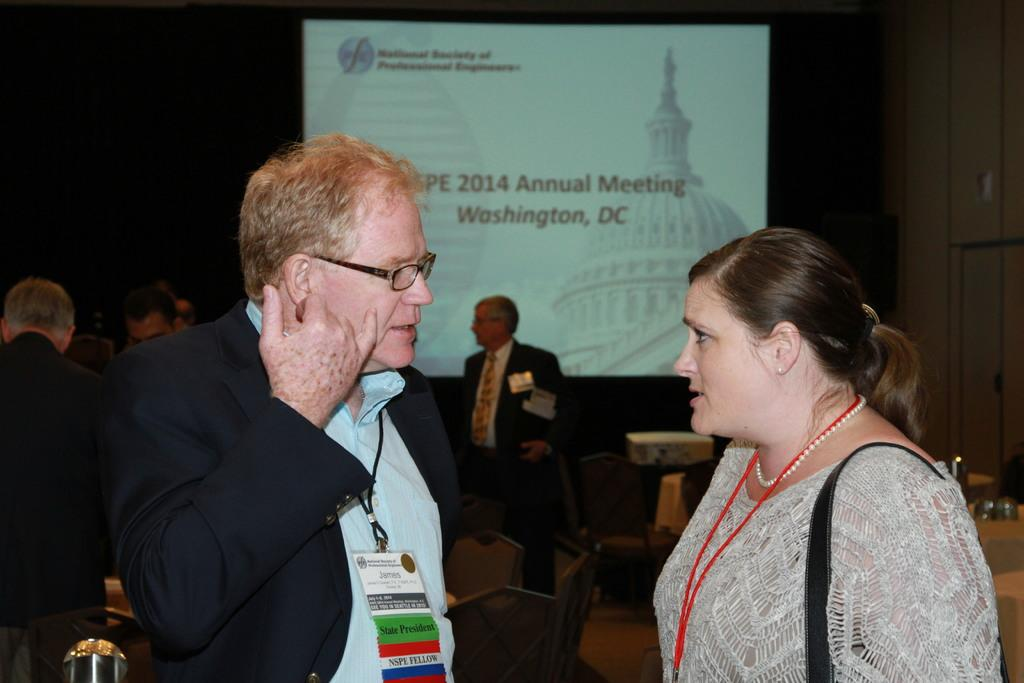How many people are in the image? There are persons standing in the image. What is the surface on which the persons are standing? The persons are standing on the floor. What objects are present between the persons? Chairs are present between the persons. What can be seen in the background of the image? There is a wall in the background of the image. What is on the wall in the image? There is a display on the wall. Can you tell me how many ladybugs are crawling on the display in the image? There are no ladybugs present in the image; the display on the wall does not show any insects. 